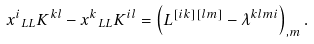<formula> <loc_0><loc_0><loc_500><loc_500>x ^ { i } { _ { L L } K ^ { k l } } - x ^ { k } { _ { L L } K ^ { i l } } = \left ( L ^ { [ i k ] [ l m ] } - \lambda ^ { k l m i } \right ) _ { , m } .</formula> 